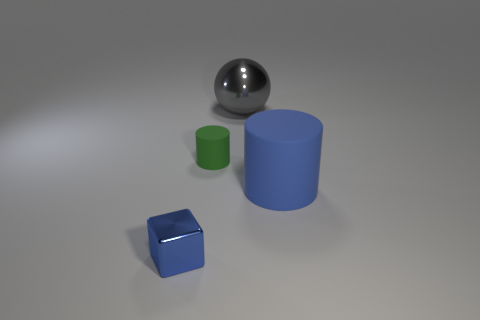Is the color of the large rubber thing the same as the small cube?
Provide a succinct answer. Yes. There is a rubber cylinder that is the same color as the tiny block; what size is it?
Your answer should be very brief. Large. What number of blue blocks have the same size as the gray thing?
Give a very brief answer. 0. There is a big thing right of the shiny object that is behind the metal thing in front of the small green cylinder; what is it made of?
Your response must be concise. Rubber. What number of things are green matte things or big matte spheres?
Your answer should be very brief. 1. What shape is the blue metal object?
Provide a short and direct response. Cube. There is a shiny thing on the left side of the thing that is behind the small green cylinder; what shape is it?
Provide a succinct answer. Cube. Do the blue thing that is to the left of the big matte thing and the gray thing have the same material?
Your answer should be very brief. Yes. How many yellow objects are either tiny matte cylinders or shiny spheres?
Your response must be concise. 0. Are there any rubber cylinders that have the same color as the small cube?
Make the answer very short. Yes. 